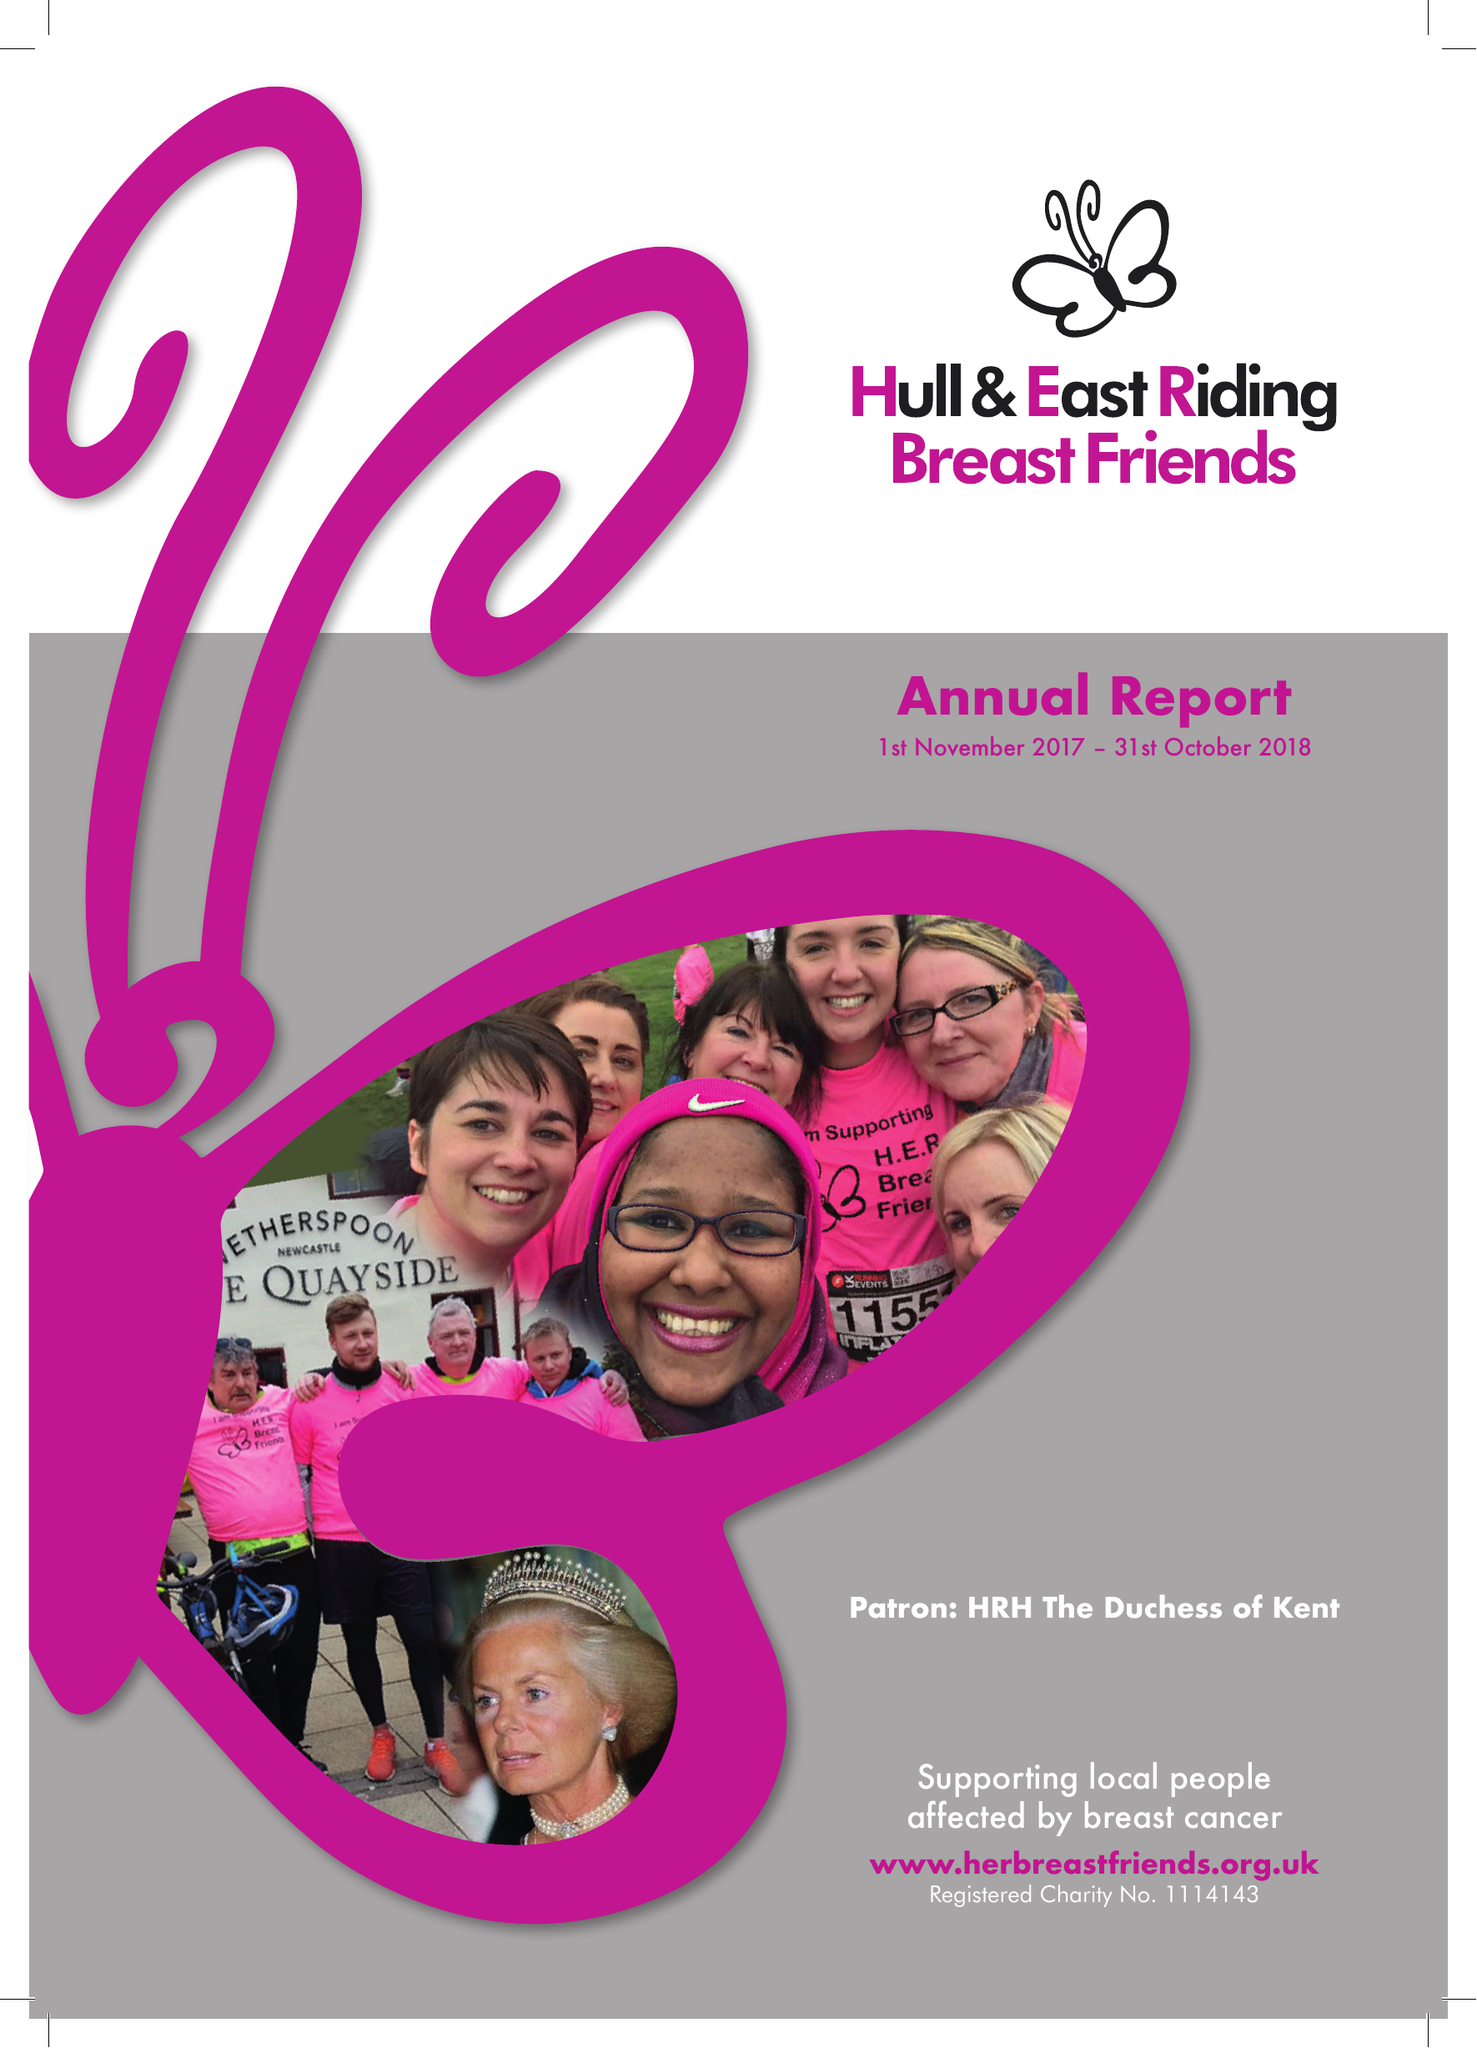What is the value for the spending_annually_in_british_pounds?
Answer the question using a single word or phrase. 46743.00 